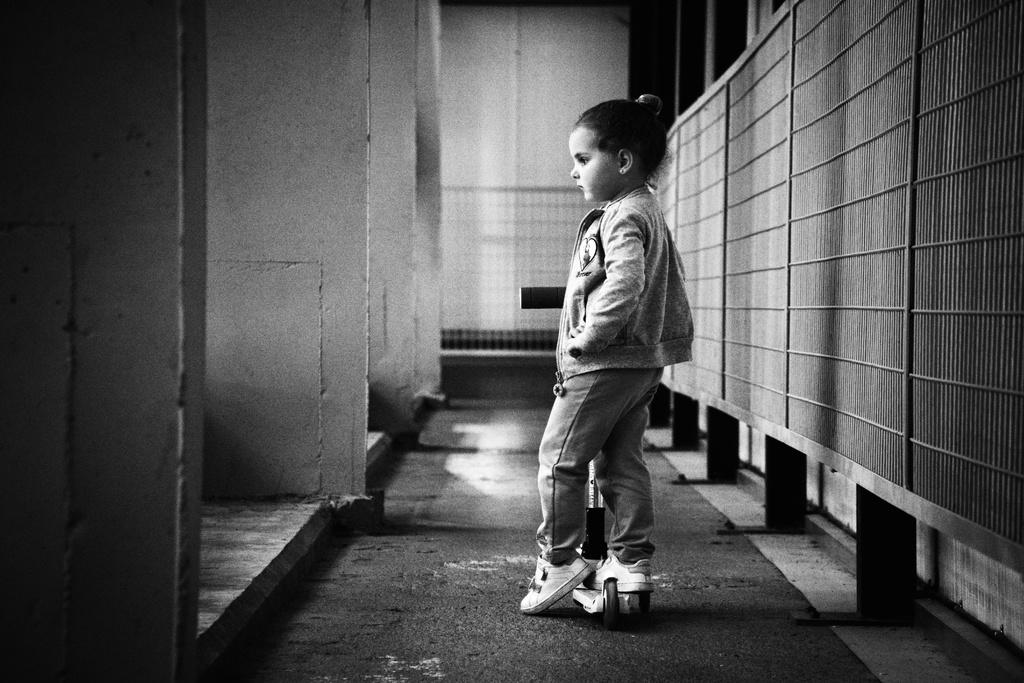Who is the main subject in the image? There is a girl in the image. What is the girl doing in the image? The girl is standing on a skateboard. What can be seen in the background of the image? There is a wall and pillars in the background of the image. What type of juice is the girl drinking in the image? There is no juice present in the image; the girl is standing on a skateboard. 